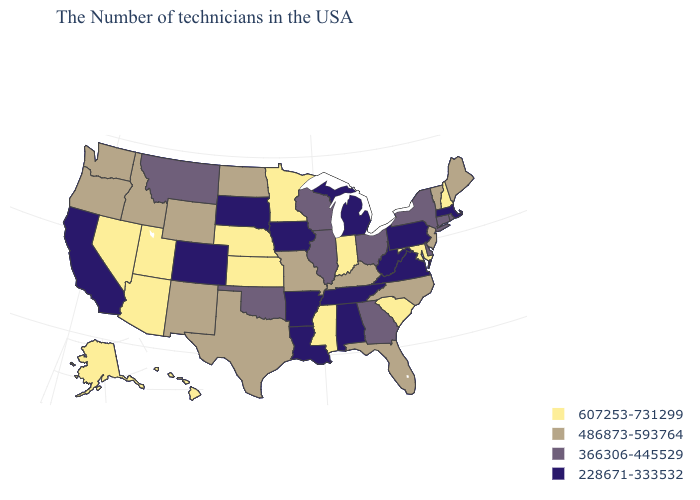What is the highest value in the MidWest ?
Keep it brief. 607253-731299. What is the value of Tennessee?
Be succinct. 228671-333532. What is the value of Oregon?
Short answer required. 486873-593764. Name the states that have a value in the range 228671-333532?
Answer briefly. Massachusetts, Pennsylvania, Virginia, West Virginia, Michigan, Alabama, Tennessee, Louisiana, Arkansas, Iowa, South Dakota, Colorado, California. What is the lowest value in states that border Virginia?
Give a very brief answer. 228671-333532. What is the value of Nevada?
Keep it brief. 607253-731299. What is the value of South Dakota?
Answer briefly. 228671-333532. Does Tennessee have a higher value than Maine?
Concise answer only. No. Name the states that have a value in the range 366306-445529?
Be succinct. Rhode Island, Connecticut, New York, Delaware, Ohio, Georgia, Wisconsin, Illinois, Oklahoma, Montana. What is the value of South Dakota?
Answer briefly. 228671-333532. Name the states that have a value in the range 228671-333532?
Answer briefly. Massachusetts, Pennsylvania, Virginia, West Virginia, Michigan, Alabama, Tennessee, Louisiana, Arkansas, Iowa, South Dakota, Colorado, California. What is the highest value in the South ?
Give a very brief answer. 607253-731299. Which states have the highest value in the USA?
Concise answer only. New Hampshire, Maryland, South Carolina, Indiana, Mississippi, Minnesota, Kansas, Nebraska, Utah, Arizona, Nevada, Alaska, Hawaii. What is the highest value in states that border Nevada?
Quick response, please. 607253-731299. 